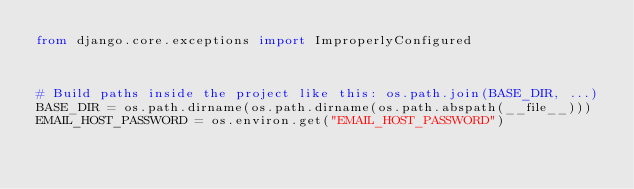Convert code to text. <code><loc_0><loc_0><loc_500><loc_500><_Python_>from django.core.exceptions import ImproperlyConfigured



# Build paths inside the project like this: os.path.join(BASE_DIR, ...)
BASE_DIR = os.path.dirname(os.path.dirname(os.path.abspath(__file__)))
EMAIL_HOST_PASSWORD = os.environ.get("EMAIL_HOST_PASSWORD")
</code> 